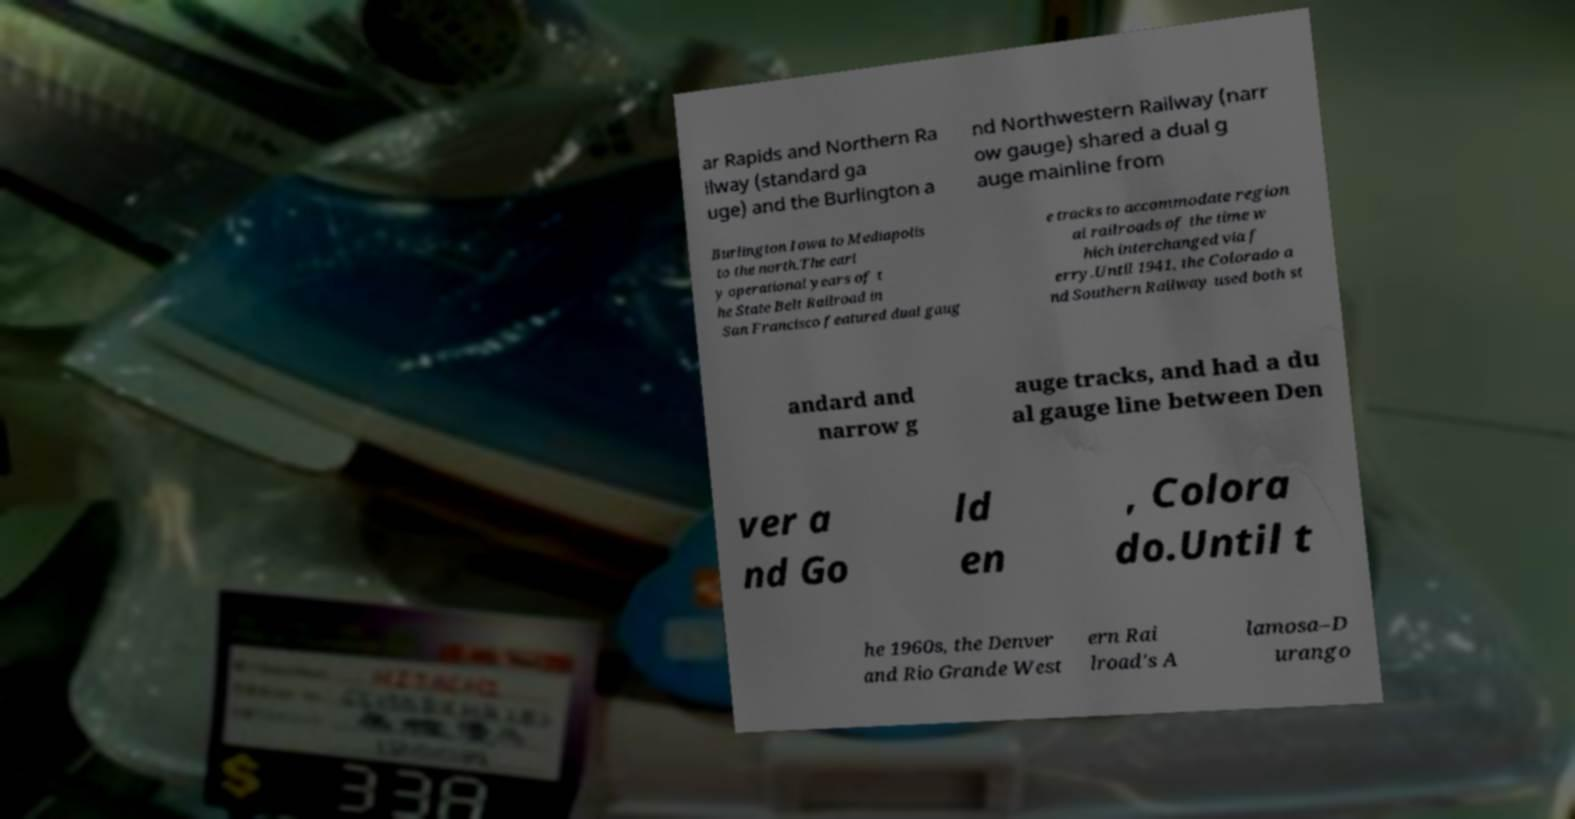There's text embedded in this image that I need extracted. Can you transcribe it verbatim? ar Rapids and Northern Ra ilway (standard ga uge) and the Burlington a nd Northwestern Railway (narr ow gauge) shared a dual g auge mainline from Burlington Iowa to Mediapolis to the north.The earl y operational years of t he State Belt Railroad in San Francisco featured dual gaug e tracks to accommodate region al railroads of the time w hich interchanged via f erry.Until 1941, the Colorado a nd Southern Railway used both st andard and narrow g auge tracks, and had a du al gauge line between Den ver a nd Go ld en , Colora do.Until t he 1960s, the Denver and Rio Grande West ern Rai lroad's A lamosa–D urango 